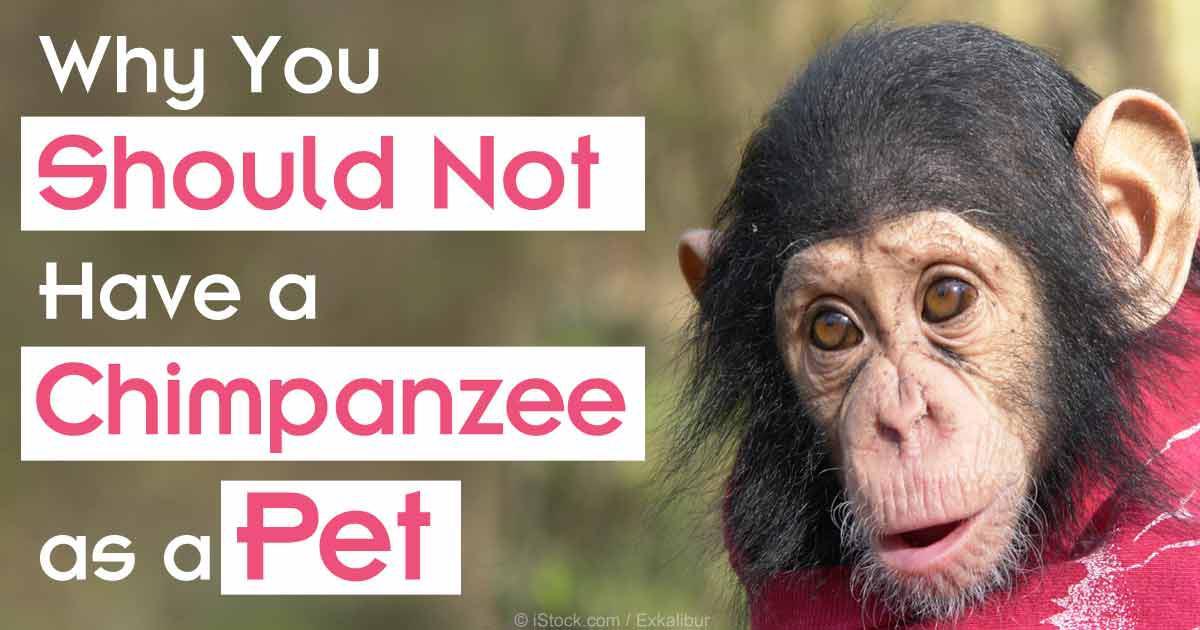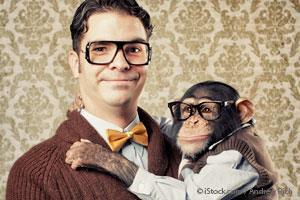The first image is the image on the left, the second image is the image on the right. Assess this claim about the two images: "An ape is holding a baby white tiger.". Correct or not? Answer yes or no. No. The first image is the image on the left, the second image is the image on the right. Evaluate the accuracy of this statement regarding the images: "there is a person in the image on the right". Is it true? Answer yes or no. Yes. 